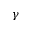<formula> <loc_0><loc_0><loc_500><loc_500>\gamma</formula> 